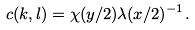<formula> <loc_0><loc_0><loc_500><loc_500>c ( k , l ) = \chi ( y / 2 ) \lambda ( x / 2 ) ^ { - 1 } .</formula> 